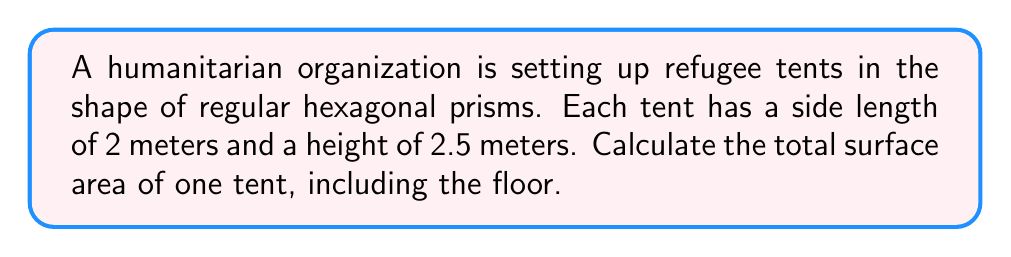Could you help me with this problem? Let's break this down step-by-step:

1) The surface area of a hexagonal prism consists of:
   - 2 hexagonal bases (top and bottom)
   - 6 rectangular sides

2) Area of one hexagonal base:
   The area of a regular hexagon is given by $A = \frac{3\sqrt{3}}{2}a^2$, where $a$ is the side length.
   $$A_{base} = \frac{3\sqrt{3}}{2}(2^2) = 6\sqrt{3} \approx 10.39 \text{ m}^2$$

3) Area of all rectangular sides:
   Each rectangle has width 2 m and height 2.5 m.
   Area of one rectangle: $2 \times 2.5 = 5 \text{ m}^2$
   There are 6 such rectangles: $6 \times 5 = 30 \text{ m}^2$

4) Total surface area:
   $$SA_{total} = 2A_{base} + 6A_{rectangle}$$
   $$SA_{total} = 2(6\sqrt{3}) + 30 = 12\sqrt{3} + 30 \approx 50.78 \text{ m}^2$$

[asy]
import geometry;

size(200);
real a = 2;
real h = 2.5;

pair[] hex = {(a,0), (a/2, a*sqrt(3)/2), (-a/2, a*sqrt(3)/2), (-a,0), (-a/2, -a*sqrt(3)/2), (a/2, -a*sqrt(3)/2)};

draw(hex[0]--hex[1]--hex[2]--hex[3]--hex[4]--hex[5]--cycle);
draw(shift(0,h)*hex[0]--shift(0,h)*hex[1]--shift(0,h)*hex[2]--shift(0,h)*hex[3]--shift(0,h)*hex[4]--shift(0,h)*hex[5]--cycle);

for (int i = 0; i < 6; ++i) {
  draw(hex[i]--shift(0,h)*hex[i]);
}

label("2 m", (hex[0]+hex[1])/2, E);
label("2.5 m", (hex[0]+shift(0,h)*hex[0])/2, E);
[/asy]
Answer: $12\sqrt{3} + 30 \text{ m}^2$ 